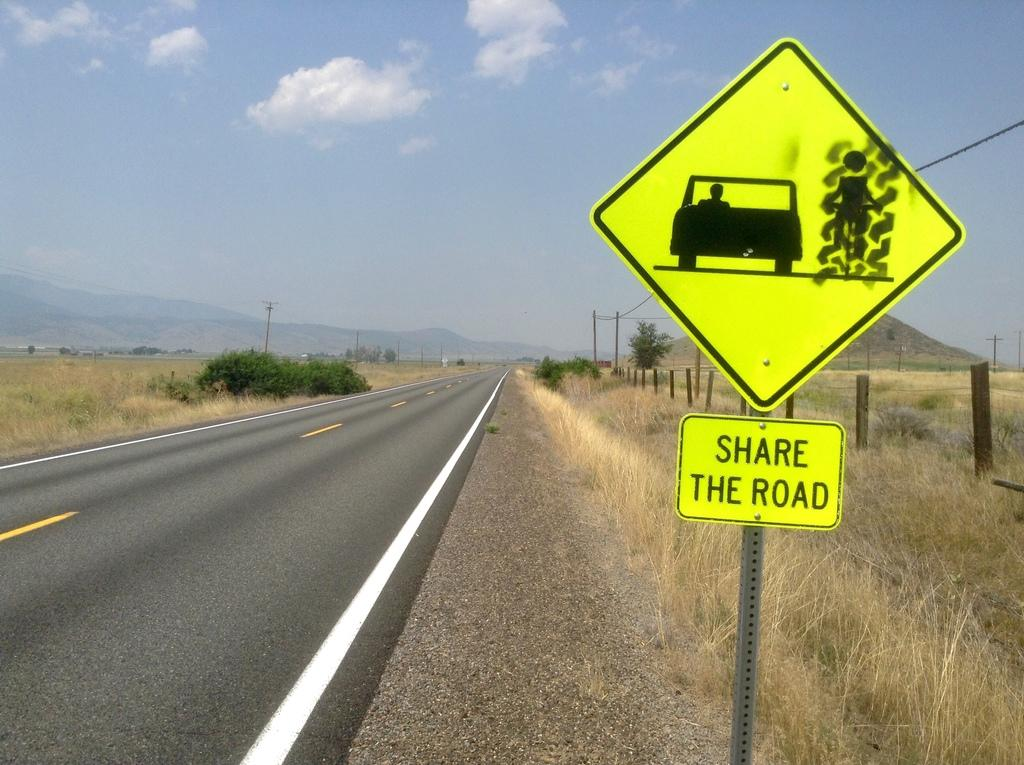<image>
Present a compact description of the photo's key features. A rural highway has a yellow neon sign that says Share The Road. 